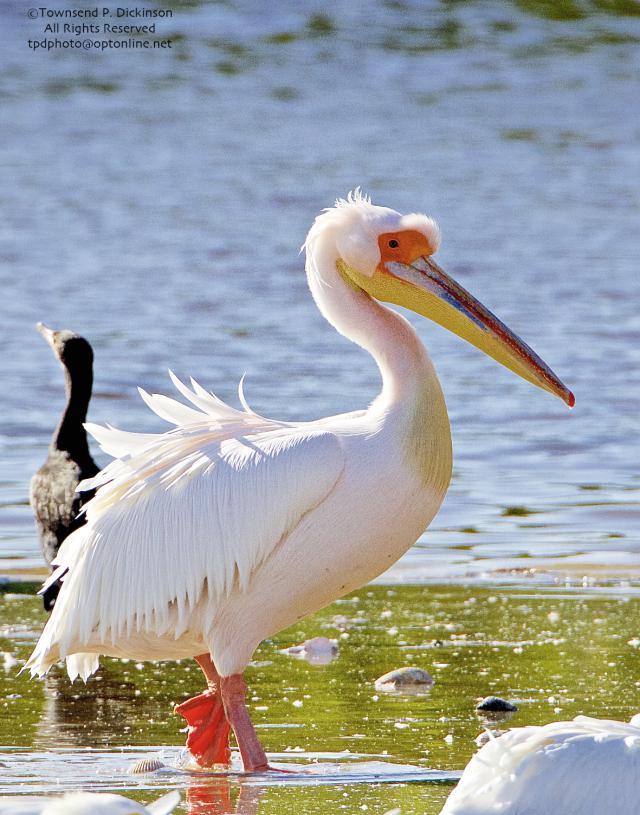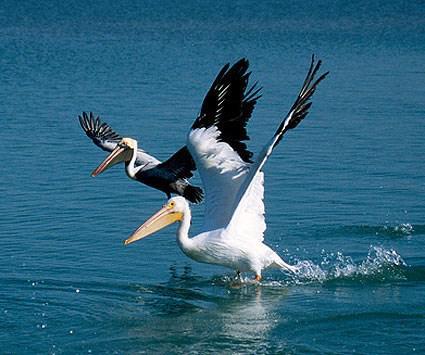The first image is the image on the left, the second image is the image on the right. Examine the images to the left and right. Is the description "there is a single pelican in flight with the wings in the downward position" accurate? Answer yes or no. No. The first image is the image on the left, the second image is the image on the right. Analyze the images presented: Is the assertion "One image shows exactly one pelican on water facing right, and the other image shows a pelican flying above water." valid? Answer yes or no. No. 